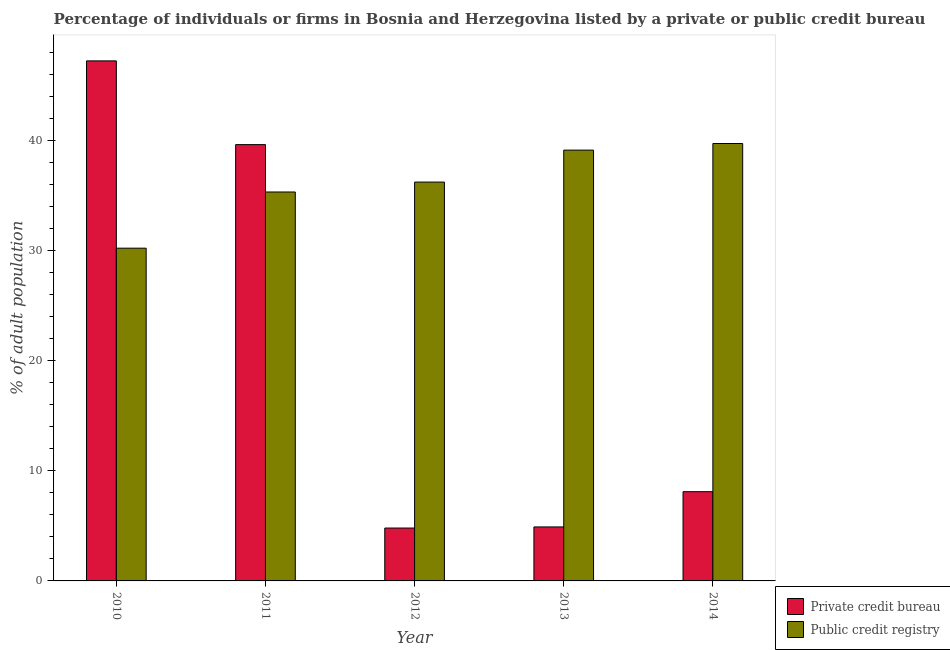How many groups of bars are there?
Provide a short and direct response. 5. Are the number of bars on each tick of the X-axis equal?
Provide a short and direct response. Yes. How many bars are there on the 4th tick from the left?
Provide a short and direct response. 2. In how many cases, is the number of bars for a given year not equal to the number of legend labels?
Make the answer very short. 0. Across all years, what is the maximum percentage of firms listed by private credit bureau?
Give a very brief answer. 47.2. Across all years, what is the minimum percentage of firms listed by private credit bureau?
Offer a terse response. 4.8. In which year was the percentage of firms listed by public credit bureau maximum?
Your answer should be compact. 2014. What is the total percentage of firms listed by private credit bureau in the graph?
Ensure brevity in your answer.  104.6. What is the difference between the percentage of firms listed by public credit bureau in 2011 and that in 2014?
Ensure brevity in your answer.  -4.4. What is the difference between the percentage of firms listed by private credit bureau in 2012 and the percentage of firms listed by public credit bureau in 2013?
Ensure brevity in your answer.  -0.1. What is the average percentage of firms listed by private credit bureau per year?
Your answer should be very brief. 20.92. In the year 2011, what is the difference between the percentage of firms listed by public credit bureau and percentage of firms listed by private credit bureau?
Give a very brief answer. 0. What is the ratio of the percentage of firms listed by public credit bureau in 2011 to that in 2012?
Keep it short and to the point. 0.98. Is the percentage of firms listed by public credit bureau in 2011 less than that in 2012?
Make the answer very short. Yes. Is the difference between the percentage of firms listed by public credit bureau in 2010 and 2011 greater than the difference between the percentage of firms listed by private credit bureau in 2010 and 2011?
Your answer should be compact. No. What is the difference between the highest and the second highest percentage of firms listed by private credit bureau?
Provide a succinct answer. 7.6. What is the difference between the highest and the lowest percentage of firms listed by public credit bureau?
Provide a short and direct response. 9.5. What does the 1st bar from the left in 2014 represents?
Your response must be concise. Private credit bureau. What does the 1st bar from the right in 2010 represents?
Give a very brief answer. Public credit registry. How many bars are there?
Provide a succinct answer. 10. What is the difference between two consecutive major ticks on the Y-axis?
Your answer should be compact. 10. Does the graph contain grids?
Your response must be concise. No. Where does the legend appear in the graph?
Provide a short and direct response. Bottom right. How many legend labels are there?
Offer a terse response. 2. What is the title of the graph?
Your response must be concise. Percentage of individuals or firms in Bosnia and Herzegovina listed by a private or public credit bureau. What is the label or title of the X-axis?
Make the answer very short. Year. What is the label or title of the Y-axis?
Provide a succinct answer. % of adult population. What is the % of adult population in Private credit bureau in 2010?
Your answer should be very brief. 47.2. What is the % of adult population in Public credit registry in 2010?
Make the answer very short. 30.2. What is the % of adult population in Private credit bureau in 2011?
Your response must be concise. 39.6. What is the % of adult population in Public credit registry in 2011?
Your answer should be very brief. 35.3. What is the % of adult population of Public credit registry in 2012?
Your answer should be very brief. 36.2. What is the % of adult population of Private credit bureau in 2013?
Provide a short and direct response. 4.9. What is the % of adult population of Public credit registry in 2013?
Your answer should be compact. 39.1. What is the % of adult population of Public credit registry in 2014?
Offer a very short reply. 39.7. Across all years, what is the maximum % of adult population of Private credit bureau?
Offer a terse response. 47.2. Across all years, what is the maximum % of adult population of Public credit registry?
Your answer should be very brief. 39.7. Across all years, what is the minimum % of adult population of Public credit registry?
Keep it short and to the point. 30.2. What is the total % of adult population in Private credit bureau in the graph?
Your answer should be very brief. 104.6. What is the total % of adult population of Public credit registry in the graph?
Give a very brief answer. 180.5. What is the difference between the % of adult population of Private credit bureau in 2010 and that in 2012?
Your answer should be very brief. 42.4. What is the difference between the % of adult population in Public credit registry in 2010 and that in 2012?
Provide a short and direct response. -6. What is the difference between the % of adult population of Private credit bureau in 2010 and that in 2013?
Offer a very short reply. 42.3. What is the difference between the % of adult population of Private credit bureau in 2010 and that in 2014?
Provide a succinct answer. 39.1. What is the difference between the % of adult population in Public credit registry in 2010 and that in 2014?
Your response must be concise. -9.5. What is the difference between the % of adult population of Private credit bureau in 2011 and that in 2012?
Your answer should be very brief. 34.8. What is the difference between the % of adult population of Public credit registry in 2011 and that in 2012?
Offer a terse response. -0.9. What is the difference between the % of adult population in Private credit bureau in 2011 and that in 2013?
Ensure brevity in your answer.  34.7. What is the difference between the % of adult population of Public credit registry in 2011 and that in 2013?
Your answer should be compact. -3.8. What is the difference between the % of adult population in Private credit bureau in 2011 and that in 2014?
Provide a short and direct response. 31.5. What is the difference between the % of adult population in Public credit registry in 2011 and that in 2014?
Your answer should be compact. -4.4. What is the difference between the % of adult population in Private credit bureau in 2012 and that in 2013?
Offer a very short reply. -0.1. What is the difference between the % of adult population in Public credit registry in 2012 and that in 2013?
Provide a succinct answer. -2.9. What is the difference between the % of adult population of Private credit bureau in 2012 and that in 2014?
Provide a short and direct response. -3.3. What is the difference between the % of adult population in Public credit registry in 2012 and that in 2014?
Your response must be concise. -3.5. What is the difference between the % of adult population of Private credit bureau in 2013 and that in 2014?
Keep it short and to the point. -3.2. What is the difference between the % of adult population in Private credit bureau in 2010 and the % of adult population in Public credit registry in 2011?
Provide a succinct answer. 11.9. What is the difference between the % of adult population in Private credit bureau in 2010 and the % of adult population in Public credit registry in 2012?
Provide a succinct answer. 11. What is the difference between the % of adult population in Private credit bureau in 2010 and the % of adult population in Public credit registry in 2013?
Your answer should be compact. 8.1. What is the difference between the % of adult population of Private credit bureau in 2010 and the % of adult population of Public credit registry in 2014?
Give a very brief answer. 7.5. What is the difference between the % of adult population in Private credit bureau in 2011 and the % of adult population in Public credit registry in 2013?
Make the answer very short. 0.5. What is the difference between the % of adult population of Private credit bureau in 2012 and the % of adult population of Public credit registry in 2013?
Ensure brevity in your answer.  -34.3. What is the difference between the % of adult population in Private credit bureau in 2012 and the % of adult population in Public credit registry in 2014?
Ensure brevity in your answer.  -34.9. What is the difference between the % of adult population in Private credit bureau in 2013 and the % of adult population in Public credit registry in 2014?
Offer a very short reply. -34.8. What is the average % of adult population of Private credit bureau per year?
Ensure brevity in your answer.  20.92. What is the average % of adult population in Public credit registry per year?
Make the answer very short. 36.1. In the year 2012, what is the difference between the % of adult population of Private credit bureau and % of adult population of Public credit registry?
Provide a succinct answer. -31.4. In the year 2013, what is the difference between the % of adult population in Private credit bureau and % of adult population in Public credit registry?
Your answer should be compact. -34.2. In the year 2014, what is the difference between the % of adult population in Private credit bureau and % of adult population in Public credit registry?
Your response must be concise. -31.6. What is the ratio of the % of adult population in Private credit bureau in 2010 to that in 2011?
Make the answer very short. 1.19. What is the ratio of the % of adult population in Public credit registry in 2010 to that in 2011?
Offer a very short reply. 0.86. What is the ratio of the % of adult population in Private credit bureau in 2010 to that in 2012?
Offer a very short reply. 9.83. What is the ratio of the % of adult population in Public credit registry in 2010 to that in 2012?
Your answer should be compact. 0.83. What is the ratio of the % of adult population in Private credit bureau in 2010 to that in 2013?
Provide a succinct answer. 9.63. What is the ratio of the % of adult population in Public credit registry in 2010 to that in 2013?
Your response must be concise. 0.77. What is the ratio of the % of adult population of Private credit bureau in 2010 to that in 2014?
Give a very brief answer. 5.83. What is the ratio of the % of adult population in Public credit registry in 2010 to that in 2014?
Make the answer very short. 0.76. What is the ratio of the % of adult population in Private credit bureau in 2011 to that in 2012?
Ensure brevity in your answer.  8.25. What is the ratio of the % of adult population in Public credit registry in 2011 to that in 2012?
Provide a short and direct response. 0.98. What is the ratio of the % of adult population in Private credit bureau in 2011 to that in 2013?
Ensure brevity in your answer.  8.08. What is the ratio of the % of adult population of Public credit registry in 2011 to that in 2013?
Make the answer very short. 0.9. What is the ratio of the % of adult population of Private credit bureau in 2011 to that in 2014?
Your answer should be compact. 4.89. What is the ratio of the % of adult population of Public credit registry in 2011 to that in 2014?
Provide a short and direct response. 0.89. What is the ratio of the % of adult population of Private credit bureau in 2012 to that in 2013?
Make the answer very short. 0.98. What is the ratio of the % of adult population in Public credit registry in 2012 to that in 2013?
Provide a succinct answer. 0.93. What is the ratio of the % of adult population of Private credit bureau in 2012 to that in 2014?
Your response must be concise. 0.59. What is the ratio of the % of adult population of Public credit registry in 2012 to that in 2014?
Make the answer very short. 0.91. What is the ratio of the % of adult population of Private credit bureau in 2013 to that in 2014?
Your answer should be compact. 0.6. What is the ratio of the % of adult population of Public credit registry in 2013 to that in 2014?
Provide a short and direct response. 0.98. What is the difference between the highest and the second highest % of adult population of Private credit bureau?
Offer a terse response. 7.6. What is the difference between the highest and the second highest % of adult population in Public credit registry?
Offer a very short reply. 0.6. What is the difference between the highest and the lowest % of adult population in Private credit bureau?
Give a very brief answer. 42.4. 